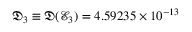<formula> <loc_0><loc_0><loc_500><loc_500>\mathfrak { D } _ { 3 } \equiv \mathfrak { D } ( \mathcal { E } _ { 3 } ) = 4 . 5 9 2 3 5 \times 1 0 ^ { - 1 3 }</formula> 